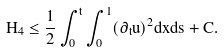<formula> <loc_0><loc_0><loc_500><loc_500>H _ { 4 } \leq \frac { 1 } { 2 } \int ^ { t } _ { 0 } \int ^ { 1 } _ { 0 } ( \partial _ { t } u ) ^ { 2 } d x d s + C .</formula> 